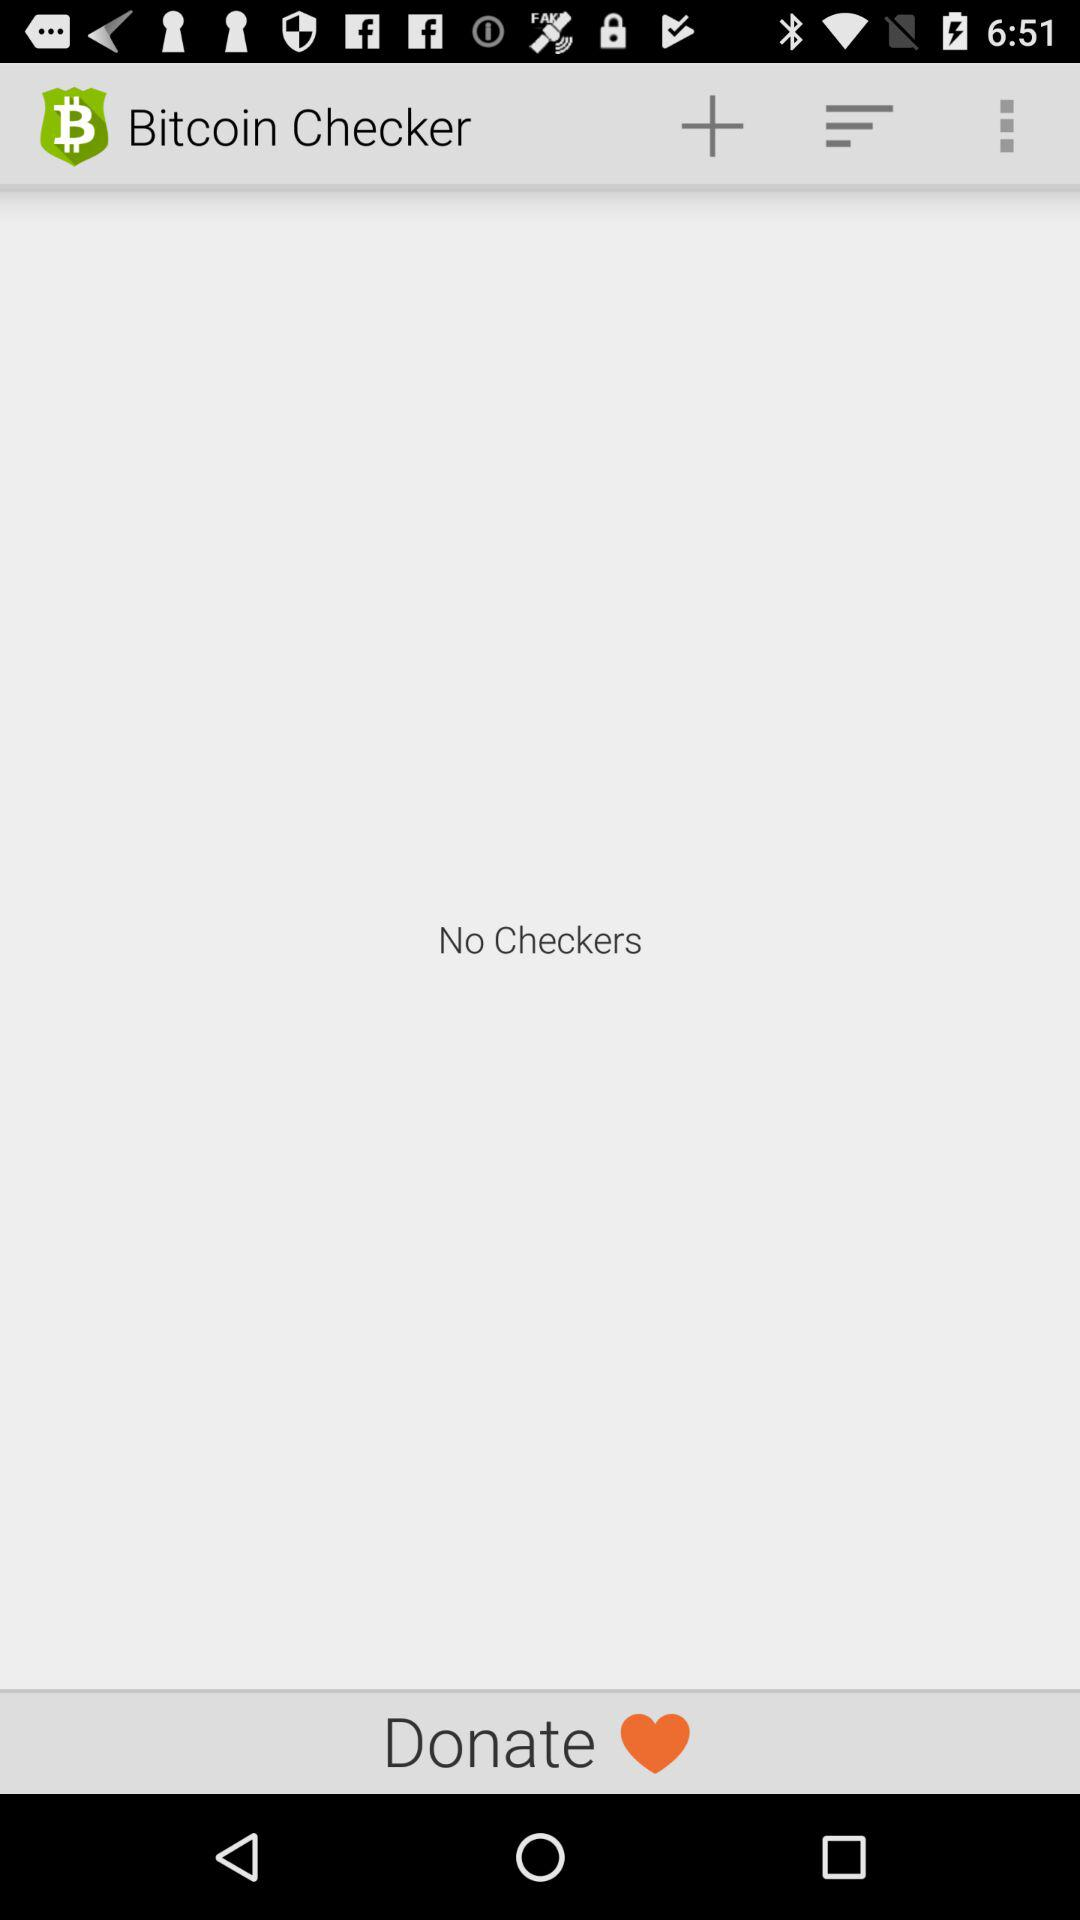Is there any "Bitcoin Checker"? There is no "Bitcoin Checker". 